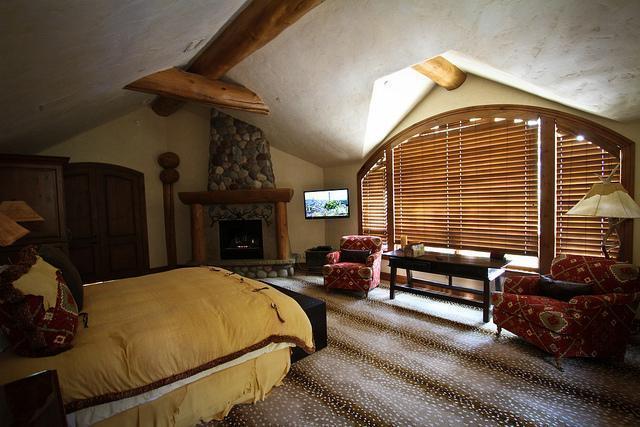What is the rectangular image in the corner of the room?
Choose the right answer and clarify with the format: 'Answer: answer
Rationale: rationale.'
Options: Poster, tablet, television, painting. Answer: television.
Rationale: The image is the tv. 